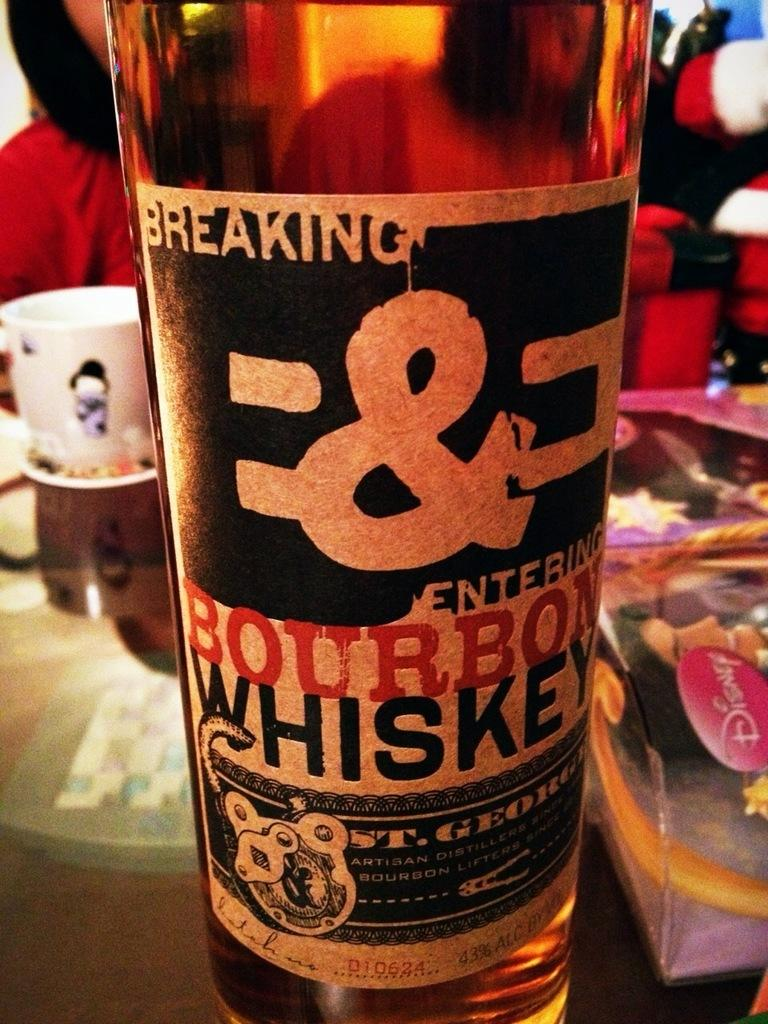<image>
Create a compact narrative representing the image presented. a bottle of liquor that is labeled 'breaking & entering, bourbon whiskey' 